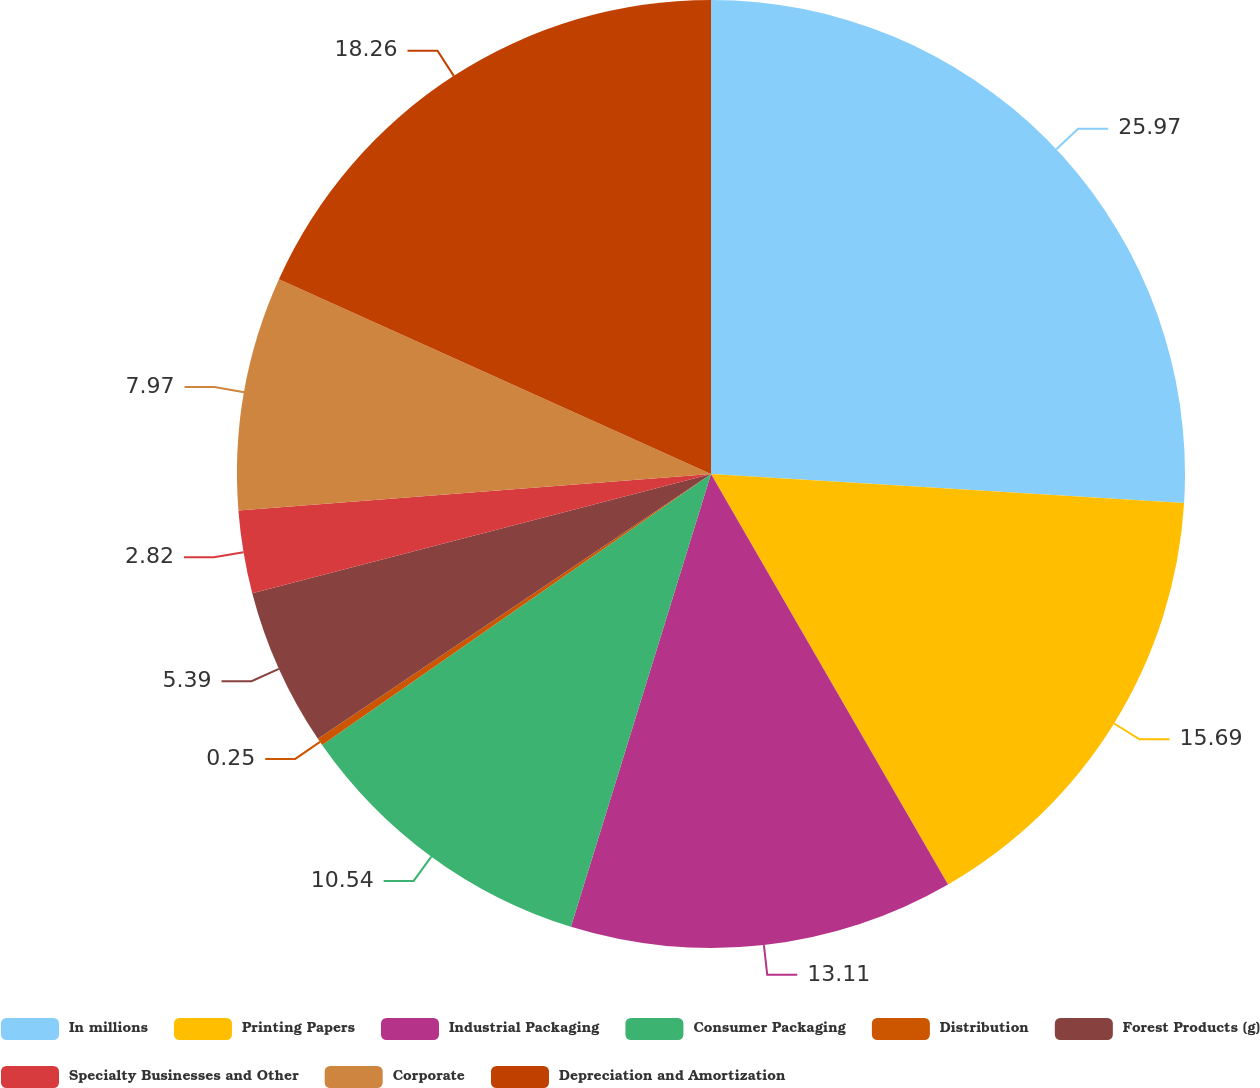Convert chart to OTSL. <chart><loc_0><loc_0><loc_500><loc_500><pie_chart><fcel>In millions<fcel>Printing Papers<fcel>Industrial Packaging<fcel>Consumer Packaging<fcel>Distribution<fcel>Forest Products (g)<fcel>Specialty Businesses and Other<fcel>Corporate<fcel>Depreciation and Amortization<nl><fcel>25.98%<fcel>15.69%<fcel>13.11%<fcel>10.54%<fcel>0.25%<fcel>5.39%<fcel>2.82%<fcel>7.97%<fcel>18.26%<nl></chart> 